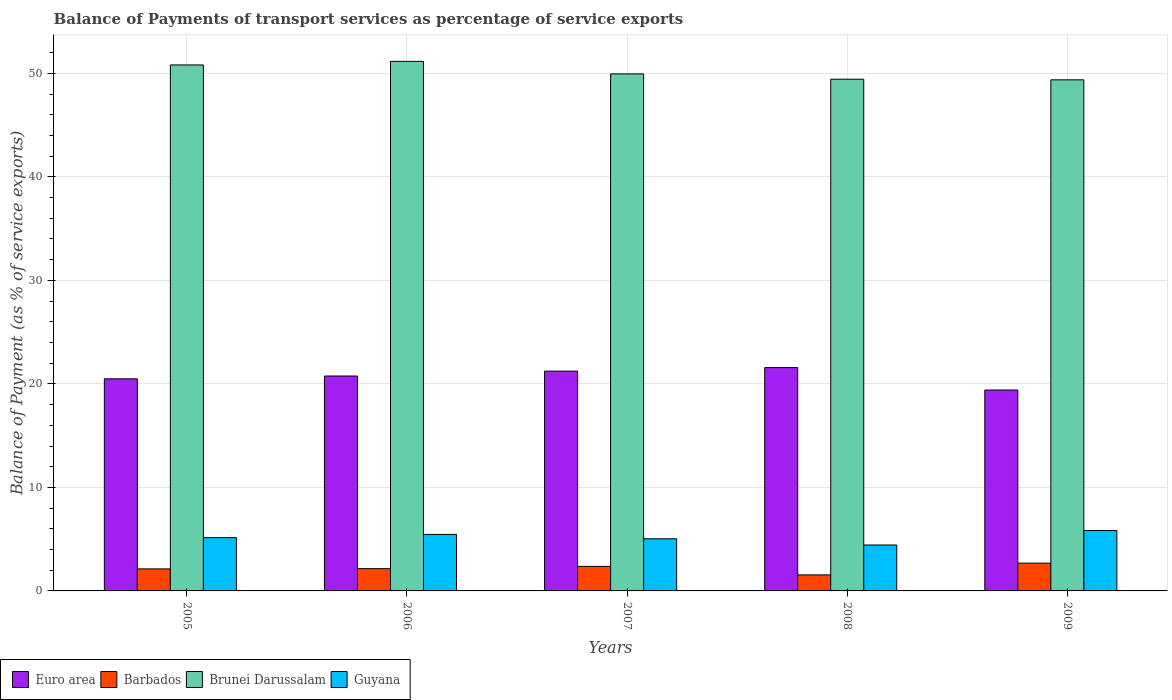How many different coloured bars are there?
Give a very brief answer. 4. How many groups of bars are there?
Your answer should be very brief. 5. Are the number of bars on each tick of the X-axis equal?
Your response must be concise. Yes. How many bars are there on the 2nd tick from the left?
Give a very brief answer. 4. How many bars are there on the 4th tick from the right?
Your response must be concise. 4. What is the label of the 1st group of bars from the left?
Give a very brief answer. 2005. What is the balance of payments of transport services in Barbados in 2007?
Provide a short and direct response. 2.37. Across all years, what is the maximum balance of payments of transport services in Guyana?
Keep it short and to the point. 5.84. Across all years, what is the minimum balance of payments of transport services in Euro area?
Keep it short and to the point. 19.41. In which year was the balance of payments of transport services in Brunei Darussalam maximum?
Keep it short and to the point. 2006. What is the total balance of payments of transport services in Brunei Darussalam in the graph?
Your response must be concise. 250.74. What is the difference between the balance of payments of transport services in Barbados in 2006 and that in 2009?
Your answer should be very brief. -0.53. What is the difference between the balance of payments of transport services in Guyana in 2007 and the balance of payments of transport services in Euro area in 2009?
Provide a succinct answer. -14.38. What is the average balance of payments of transport services in Brunei Darussalam per year?
Keep it short and to the point. 50.15. In the year 2007, what is the difference between the balance of payments of transport services in Euro area and balance of payments of transport services in Barbados?
Your answer should be compact. 18.86. In how many years, is the balance of payments of transport services in Euro area greater than 22 %?
Ensure brevity in your answer.  0. What is the ratio of the balance of payments of transport services in Guyana in 2007 to that in 2008?
Your answer should be compact. 1.13. Is the balance of payments of transport services in Barbados in 2005 less than that in 2007?
Keep it short and to the point. Yes. Is the difference between the balance of payments of transport services in Euro area in 2007 and 2009 greater than the difference between the balance of payments of transport services in Barbados in 2007 and 2009?
Your answer should be compact. Yes. What is the difference between the highest and the second highest balance of payments of transport services in Barbados?
Your response must be concise. 0.31. What is the difference between the highest and the lowest balance of payments of transport services in Euro area?
Give a very brief answer. 2.17. Is it the case that in every year, the sum of the balance of payments of transport services in Guyana and balance of payments of transport services in Barbados is greater than the sum of balance of payments of transport services in Euro area and balance of payments of transport services in Brunei Darussalam?
Offer a terse response. Yes. What does the 2nd bar from the left in 2008 represents?
Give a very brief answer. Barbados. What does the 3rd bar from the right in 2009 represents?
Offer a very short reply. Barbados. Is it the case that in every year, the sum of the balance of payments of transport services in Brunei Darussalam and balance of payments of transport services in Guyana is greater than the balance of payments of transport services in Barbados?
Your answer should be compact. Yes. Are all the bars in the graph horizontal?
Offer a terse response. No. How many years are there in the graph?
Provide a short and direct response. 5. How many legend labels are there?
Offer a very short reply. 4. What is the title of the graph?
Provide a short and direct response. Balance of Payments of transport services as percentage of service exports. What is the label or title of the Y-axis?
Your response must be concise. Balance of Payment (as % of service exports). What is the Balance of Payment (as % of service exports) in Euro area in 2005?
Keep it short and to the point. 20.49. What is the Balance of Payment (as % of service exports) of Barbados in 2005?
Provide a succinct answer. 2.13. What is the Balance of Payment (as % of service exports) of Brunei Darussalam in 2005?
Make the answer very short. 50.81. What is the Balance of Payment (as % of service exports) of Guyana in 2005?
Offer a terse response. 5.15. What is the Balance of Payment (as % of service exports) in Euro area in 2006?
Keep it short and to the point. 20.76. What is the Balance of Payment (as % of service exports) in Barbados in 2006?
Provide a succinct answer. 2.15. What is the Balance of Payment (as % of service exports) in Brunei Darussalam in 2006?
Ensure brevity in your answer.  51.16. What is the Balance of Payment (as % of service exports) of Guyana in 2006?
Your answer should be compact. 5.46. What is the Balance of Payment (as % of service exports) in Euro area in 2007?
Provide a succinct answer. 21.23. What is the Balance of Payment (as % of service exports) of Barbados in 2007?
Keep it short and to the point. 2.37. What is the Balance of Payment (as % of service exports) in Brunei Darussalam in 2007?
Give a very brief answer. 49.95. What is the Balance of Payment (as % of service exports) in Guyana in 2007?
Provide a succinct answer. 5.03. What is the Balance of Payment (as % of service exports) of Euro area in 2008?
Your answer should be compact. 21.58. What is the Balance of Payment (as % of service exports) in Barbados in 2008?
Ensure brevity in your answer.  1.55. What is the Balance of Payment (as % of service exports) of Brunei Darussalam in 2008?
Your response must be concise. 49.44. What is the Balance of Payment (as % of service exports) in Guyana in 2008?
Your answer should be very brief. 4.44. What is the Balance of Payment (as % of service exports) of Euro area in 2009?
Provide a short and direct response. 19.41. What is the Balance of Payment (as % of service exports) of Barbados in 2009?
Make the answer very short. 2.68. What is the Balance of Payment (as % of service exports) in Brunei Darussalam in 2009?
Make the answer very short. 49.38. What is the Balance of Payment (as % of service exports) in Guyana in 2009?
Give a very brief answer. 5.84. Across all years, what is the maximum Balance of Payment (as % of service exports) in Euro area?
Your answer should be compact. 21.58. Across all years, what is the maximum Balance of Payment (as % of service exports) in Barbados?
Provide a short and direct response. 2.68. Across all years, what is the maximum Balance of Payment (as % of service exports) in Brunei Darussalam?
Provide a succinct answer. 51.16. Across all years, what is the maximum Balance of Payment (as % of service exports) in Guyana?
Make the answer very short. 5.84. Across all years, what is the minimum Balance of Payment (as % of service exports) in Euro area?
Provide a succinct answer. 19.41. Across all years, what is the minimum Balance of Payment (as % of service exports) of Barbados?
Provide a short and direct response. 1.55. Across all years, what is the minimum Balance of Payment (as % of service exports) of Brunei Darussalam?
Offer a terse response. 49.38. Across all years, what is the minimum Balance of Payment (as % of service exports) in Guyana?
Your answer should be compact. 4.44. What is the total Balance of Payment (as % of service exports) in Euro area in the graph?
Provide a short and direct response. 103.47. What is the total Balance of Payment (as % of service exports) of Barbados in the graph?
Provide a short and direct response. 10.89. What is the total Balance of Payment (as % of service exports) of Brunei Darussalam in the graph?
Offer a terse response. 250.74. What is the total Balance of Payment (as % of service exports) in Guyana in the graph?
Provide a succinct answer. 25.91. What is the difference between the Balance of Payment (as % of service exports) of Euro area in 2005 and that in 2006?
Your response must be concise. -0.27. What is the difference between the Balance of Payment (as % of service exports) of Barbados in 2005 and that in 2006?
Your answer should be compact. -0.02. What is the difference between the Balance of Payment (as % of service exports) of Brunei Darussalam in 2005 and that in 2006?
Your answer should be compact. -0.35. What is the difference between the Balance of Payment (as % of service exports) of Guyana in 2005 and that in 2006?
Ensure brevity in your answer.  -0.31. What is the difference between the Balance of Payment (as % of service exports) in Euro area in 2005 and that in 2007?
Keep it short and to the point. -0.74. What is the difference between the Balance of Payment (as % of service exports) in Barbados in 2005 and that in 2007?
Offer a very short reply. -0.24. What is the difference between the Balance of Payment (as % of service exports) in Brunei Darussalam in 2005 and that in 2007?
Provide a short and direct response. 0.86. What is the difference between the Balance of Payment (as % of service exports) of Guyana in 2005 and that in 2007?
Offer a very short reply. 0.11. What is the difference between the Balance of Payment (as % of service exports) of Euro area in 2005 and that in 2008?
Make the answer very short. -1.09. What is the difference between the Balance of Payment (as % of service exports) in Barbados in 2005 and that in 2008?
Keep it short and to the point. 0.58. What is the difference between the Balance of Payment (as % of service exports) of Brunei Darussalam in 2005 and that in 2008?
Your answer should be very brief. 1.38. What is the difference between the Balance of Payment (as % of service exports) of Guyana in 2005 and that in 2008?
Ensure brevity in your answer.  0.71. What is the difference between the Balance of Payment (as % of service exports) of Euro area in 2005 and that in 2009?
Your answer should be compact. 1.08. What is the difference between the Balance of Payment (as % of service exports) of Barbados in 2005 and that in 2009?
Offer a terse response. -0.56. What is the difference between the Balance of Payment (as % of service exports) in Brunei Darussalam in 2005 and that in 2009?
Provide a short and direct response. 1.44. What is the difference between the Balance of Payment (as % of service exports) in Guyana in 2005 and that in 2009?
Give a very brief answer. -0.69. What is the difference between the Balance of Payment (as % of service exports) in Euro area in 2006 and that in 2007?
Provide a short and direct response. -0.47. What is the difference between the Balance of Payment (as % of service exports) of Barbados in 2006 and that in 2007?
Make the answer very short. -0.22. What is the difference between the Balance of Payment (as % of service exports) in Brunei Darussalam in 2006 and that in 2007?
Provide a succinct answer. 1.21. What is the difference between the Balance of Payment (as % of service exports) of Guyana in 2006 and that in 2007?
Your response must be concise. 0.42. What is the difference between the Balance of Payment (as % of service exports) in Euro area in 2006 and that in 2008?
Make the answer very short. -0.81. What is the difference between the Balance of Payment (as % of service exports) in Barbados in 2006 and that in 2008?
Provide a succinct answer. 0.6. What is the difference between the Balance of Payment (as % of service exports) of Brunei Darussalam in 2006 and that in 2008?
Provide a succinct answer. 1.73. What is the difference between the Balance of Payment (as % of service exports) in Guyana in 2006 and that in 2008?
Ensure brevity in your answer.  1.02. What is the difference between the Balance of Payment (as % of service exports) in Euro area in 2006 and that in 2009?
Your answer should be compact. 1.35. What is the difference between the Balance of Payment (as % of service exports) in Barbados in 2006 and that in 2009?
Give a very brief answer. -0.53. What is the difference between the Balance of Payment (as % of service exports) of Brunei Darussalam in 2006 and that in 2009?
Ensure brevity in your answer.  1.79. What is the difference between the Balance of Payment (as % of service exports) in Guyana in 2006 and that in 2009?
Your answer should be compact. -0.38. What is the difference between the Balance of Payment (as % of service exports) of Euro area in 2007 and that in 2008?
Make the answer very short. -0.34. What is the difference between the Balance of Payment (as % of service exports) of Barbados in 2007 and that in 2008?
Give a very brief answer. 0.82. What is the difference between the Balance of Payment (as % of service exports) in Brunei Darussalam in 2007 and that in 2008?
Your answer should be very brief. 0.51. What is the difference between the Balance of Payment (as % of service exports) in Guyana in 2007 and that in 2008?
Ensure brevity in your answer.  0.6. What is the difference between the Balance of Payment (as % of service exports) of Euro area in 2007 and that in 2009?
Your answer should be compact. 1.82. What is the difference between the Balance of Payment (as % of service exports) in Barbados in 2007 and that in 2009?
Give a very brief answer. -0.31. What is the difference between the Balance of Payment (as % of service exports) in Brunei Darussalam in 2007 and that in 2009?
Offer a very short reply. 0.57. What is the difference between the Balance of Payment (as % of service exports) of Guyana in 2007 and that in 2009?
Offer a terse response. -0.8. What is the difference between the Balance of Payment (as % of service exports) in Euro area in 2008 and that in 2009?
Give a very brief answer. 2.17. What is the difference between the Balance of Payment (as % of service exports) in Barbados in 2008 and that in 2009?
Make the answer very short. -1.13. What is the difference between the Balance of Payment (as % of service exports) in Brunei Darussalam in 2008 and that in 2009?
Keep it short and to the point. 0.06. What is the difference between the Balance of Payment (as % of service exports) in Guyana in 2008 and that in 2009?
Offer a terse response. -1.4. What is the difference between the Balance of Payment (as % of service exports) of Euro area in 2005 and the Balance of Payment (as % of service exports) of Barbados in 2006?
Keep it short and to the point. 18.34. What is the difference between the Balance of Payment (as % of service exports) of Euro area in 2005 and the Balance of Payment (as % of service exports) of Brunei Darussalam in 2006?
Give a very brief answer. -30.67. What is the difference between the Balance of Payment (as % of service exports) of Euro area in 2005 and the Balance of Payment (as % of service exports) of Guyana in 2006?
Offer a terse response. 15.03. What is the difference between the Balance of Payment (as % of service exports) of Barbados in 2005 and the Balance of Payment (as % of service exports) of Brunei Darussalam in 2006?
Keep it short and to the point. -49.03. What is the difference between the Balance of Payment (as % of service exports) in Barbados in 2005 and the Balance of Payment (as % of service exports) in Guyana in 2006?
Your response must be concise. -3.33. What is the difference between the Balance of Payment (as % of service exports) in Brunei Darussalam in 2005 and the Balance of Payment (as % of service exports) in Guyana in 2006?
Provide a succinct answer. 45.36. What is the difference between the Balance of Payment (as % of service exports) of Euro area in 2005 and the Balance of Payment (as % of service exports) of Barbados in 2007?
Keep it short and to the point. 18.12. What is the difference between the Balance of Payment (as % of service exports) in Euro area in 2005 and the Balance of Payment (as % of service exports) in Brunei Darussalam in 2007?
Your answer should be very brief. -29.46. What is the difference between the Balance of Payment (as % of service exports) of Euro area in 2005 and the Balance of Payment (as % of service exports) of Guyana in 2007?
Provide a succinct answer. 15.46. What is the difference between the Balance of Payment (as % of service exports) of Barbados in 2005 and the Balance of Payment (as % of service exports) of Brunei Darussalam in 2007?
Your answer should be very brief. -47.82. What is the difference between the Balance of Payment (as % of service exports) in Barbados in 2005 and the Balance of Payment (as % of service exports) in Guyana in 2007?
Provide a succinct answer. -2.91. What is the difference between the Balance of Payment (as % of service exports) of Brunei Darussalam in 2005 and the Balance of Payment (as % of service exports) of Guyana in 2007?
Make the answer very short. 45.78. What is the difference between the Balance of Payment (as % of service exports) in Euro area in 2005 and the Balance of Payment (as % of service exports) in Barbados in 2008?
Your answer should be very brief. 18.94. What is the difference between the Balance of Payment (as % of service exports) in Euro area in 2005 and the Balance of Payment (as % of service exports) in Brunei Darussalam in 2008?
Your answer should be compact. -28.94. What is the difference between the Balance of Payment (as % of service exports) of Euro area in 2005 and the Balance of Payment (as % of service exports) of Guyana in 2008?
Give a very brief answer. 16.05. What is the difference between the Balance of Payment (as % of service exports) in Barbados in 2005 and the Balance of Payment (as % of service exports) in Brunei Darussalam in 2008?
Give a very brief answer. -47.31. What is the difference between the Balance of Payment (as % of service exports) in Barbados in 2005 and the Balance of Payment (as % of service exports) in Guyana in 2008?
Your answer should be very brief. -2.31. What is the difference between the Balance of Payment (as % of service exports) of Brunei Darussalam in 2005 and the Balance of Payment (as % of service exports) of Guyana in 2008?
Offer a very short reply. 46.38. What is the difference between the Balance of Payment (as % of service exports) of Euro area in 2005 and the Balance of Payment (as % of service exports) of Barbados in 2009?
Give a very brief answer. 17.81. What is the difference between the Balance of Payment (as % of service exports) in Euro area in 2005 and the Balance of Payment (as % of service exports) in Brunei Darussalam in 2009?
Make the answer very short. -28.88. What is the difference between the Balance of Payment (as % of service exports) of Euro area in 2005 and the Balance of Payment (as % of service exports) of Guyana in 2009?
Ensure brevity in your answer.  14.66. What is the difference between the Balance of Payment (as % of service exports) in Barbados in 2005 and the Balance of Payment (as % of service exports) in Brunei Darussalam in 2009?
Ensure brevity in your answer.  -47.25. What is the difference between the Balance of Payment (as % of service exports) in Barbados in 2005 and the Balance of Payment (as % of service exports) in Guyana in 2009?
Provide a short and direct response. -3.71. What is the difference between the Balance of Payment (as % of service exports) in Brunei Darussalam in 2005 and the Balance of Payment (as % of service exports) in Guyana in 2009?
Keep it short and to the point. 44.98. What is the difference between the Balance of Payment (as % of service exports) in Euro area in 2006 and the Balance of Payment (as % of service exports) in Barbados in 2007?
Offer a very short reply. 18.39. What is the difference between the Balance of Payment (as % of service exports) in Euro area in 2006 and the Balance of Payment (as % of service exports) in Brunei Darussalam in 2007?
Ensure brevity in your answer.  -29.19. What is the difference between the Balance of Payment (as % of service exports) in Euro area in 2006 and the Balance of Payment (as % of service exports) in Guyana in 2007?
Your answer should be very brief. 15.73. What is the difference between the Balance of Payment (as % of service exports) in Barbados in 2006 and the Balance of Payment (as % of service exports) in Brunei Darussalam in 2007?
Keep it short and to the point. -47.8. What is the difference between the Balance of Payment (as % of service exports) of Barbados in 2006 and the Balance of Payment (as % of service exports) of Guyana in 2007?
Offer a very short reply. -2.88. What is the difference between the Balance of Payment (as % of service exports) of Brunei Darussalam in 2006 and the Balance of Payment (as % of service exports) of Guyana in 2007?
Your answer should be compact. 46.13. What is the difference between the Balance of Payment (as % of service exports) of Euro area in 2006 and the Balance of Payment (as % of service exports) of Barbados in 2008?
Ensure brevity in your answer.  19.21. What is the difference between the Balance of Payment (as % of service exports) in Euro area in 2006 and the Balance of Payment (as % of service exports) in Brunei Darussalam in 2008?
Provide a short and direct response. -28.67. What is the difference between the Balance of Payment (as % of service exports) in Euro area in 2006 and the Balance of Payment (as % of service exports) in Guyana in 2008?
Provide a short and direct response. 16.33. What is the difference between the Balance of Payment (as % of service exports) in Barbados in 2006 and the Balance of Payment (as % of service exports) in Brunei Darussalam in 2008?
Your response must be concise. -47.28. What is the difference between the Balance of Payment (as % of service exports) in Barbados in 2006 and the Balance of Payment (as % of service exports) in Guyana in 2008?
Make the answer very short. -2.29. What is the difference between the Balance of Payment (as % of service exports) of Brunei Darussalam in 2006 and the Balance of Payment (as % of service exports) of Guyana in 2008?
Ensure brevity in your answer.  46.72. What is the difference between the Balance of Payment (as % of service exports) in Euro area in 2006 and the Balance of Payment (as % of service exports) in Barbados in 2009?
Keep it short and to the point. 18.08. What is the difference between the Balance of Payment (as % of service exports) of Euro area in 2006 and the Balance of Payment (as % of service exports) of Brunei Darussalam in 2009?
Keep it short and to the point. -28.61. What is the difference between the Balance of Payment (as % of service exports) of Euro area in 2006 and the Balance of Payment (as % of service exports) of Guyana in 2009?
Provide a succinct answer. 14.93. What is the difference between the Balance of Payment (as % of service exports) in Barbados in 2006 and the Balance of Payment (as % of service exports) in Brunei Darussalam in 2009?
Your response must be concise. -47.22. What is the difference between the Balance of Payment (as % of service exports) in Barbados in 2006 and the Balance of Payment (as % of service exports) in Guyana in 2009?
Your answer should be very brief. -3.68. What is the difference between the Balance of Payment (as % of service exports) of Brunei Darussalam in 2006 and the Balance of Payment (as % of service exports) of Guyana in 2009?
Your answer should be compact. 45.33. What is the difference between the Balance of Payment (as % of service exports) of Euro area in 2007 and the Balance of Payment (as % of service exports) of Barbados in 2008?
Make the answer very short. 19.68. What is the difference between the Balance of Payment (as % of service exports) in Euro area in 2007 and the Balance of Payment (as % of service exports) in Brunei Darussalam in 2008?
Offer a terse response. -28.2. What is the difference between the Balance of Payment (as % of service exports) in Euro area in 2007 and the Balance of Payment (as % of service exports) in Guyana in 2008?
Ensure brevity in your answer.  16.8. What is the difference between the Balance of Payment (as % of service exports) of Barbados in 2007 and the Balance of Payment (as % of service exports) of Brunei Darussalam in 2008?
Your response must be concise. -47.06. What is the difference between the Balance of Payment (as % of service exports) of Barbados in 2007 and the Balance of Payment (as % of service exports) of Guyana in 2008?
Provide a succinct answer. -2.06. What is the difference between the Balance of Payment (as % of service exports) in Brunei Darussalam in 2007 and the Balance of Payment (as % of service exports) in Guyana in 2008?
Your answer should be very brief. 45.51. What is the difference between the Balance of Payment (as % of service exports) of Euro area in 2007 and the Balance of Payment (as % of service exports) of Barbados in 2009?
Your answer should be compact. 18.55. What is the difference between the Balance of Payment (as % of service exports) of Euro area in 2007 and the Balance of Payment (as % of service exports) of Brunei Darussalam in 2009?
Make the answer very short. -28.14. What is the difference between the Balance of Payment (as % of service exports) of Euro area in 2007 and the Balance of Payment (as % of service exports) of Guyana in 2009?
Keep it short and to the point. 15.4. What is the difference between the Balance of Payment (as % of service exports) in Barbados in 2007 and the Balance of Payment (as % of service exports) in Brunei Darussalam in 2009?
Offer a terse response. -47. What is the difference between the Balance of Payment (as % of service exports) of Barbados in 2007 and the Balance of Payment (as % of service exports) of Guyana in 2009?
Provide a short and direct response. -3.46. What is the difference between the Balance of Payment (as % of service exports) of Brunei Darussalam in 2007 and the Balance of Payment (as % of service exports) of Guyana in 2009?
Give a very brief answer. 44.11. What is the difference between the Balance of Payment (as % of service exports) of Euro area in 2008 and the Balance of Payment (as % of service exports) of Barbados in 2009?
Offer a terse response. 18.89. What is the difference between the Balance of Payment (as % of service exports) in Euro area in 2008 and the Balance of Payment (as % of service exports) in Brunei Darussalam in 2009?
Keep it short and to the point. -27.8. What is the difference between the Balance of Payment (as % of service exports) of Euro area in 2008 and the Balance of Payment (as % of service exports) of Guyana in 2009?
Your answer should be compact. 15.74. What is the difference between the Balance of Payment (as % of service exports) in Barbados in 2008 and the Balance of Payment (as % of service exports) in Brunei Darussalam in 2009?
Make the answer very short. -47.83. What is the difference between the Balance of Payment (as % of service exports) in Barbados in 2008 and the Balance of Payment (as % of service exports) in Guyana in 2009?
Make the answer very short. -4.29. What is the difference between the Balance of Payment (as % of service exports) in Brunei Darussalam in 2008 and the Balance of Payment (as % of service exports) in Guyana in 2009?
Provide a short and direct response. 43.6. What is the average Balance of Payment (as % of service exports) of Euro area per year?
Your answer should be compact. 20.69. What is the average Balance of Payment (as % of service exports) in Barbados per year?
Make the answer very short. 2.18. What is the average Balance of Payment (as % of service exports) of Brunei Darussalam per year?
Give a very brief answer. 50.15. What is the average Balance of Payment (as % of service exports) of Guyana per year?
Ensure brevity in your answer.  5.18. In the year 2005, what is the difference between the Balance of Payment (as % of service exports) in Euro area and Balance of Payment (as % of service exports) in Barbados?
Make the answer very short. 18.36. In the year 2005, what is the difference between the Balance of Payment (as % of service exports) of Euro area and Balance of Payment (as % of service exports) of Brunei Darussalam?
Ensure brevity in your answer.  -30.32. In the year 2005, what is the difference between the Balance of Payment (as % of service exports) in Euro area and Balance of Payment (as % of service exports) in Guyana?
Offer a very short reply. 15.35. In the year 2005, what is the difference between the Balance of Payment (as % of service exports) of Barbados and Balance of Payment (as % of service exports) of Brunei Darussalam?
Make the answer very short. -48.69. In the year 2005, what is the difference between the Balance of Payment (as % of service exports) in Barbados and Balance of Payment (as % of service exports) in Guyana?
Provide a succinct answer. -3.02. In the year 2005, what is the difference between the Balance of Payment (as % of service exports) in Brunei Darussalam and Balance of Payment (as % of service exports) in Guyana?
Provide a succinct answer. 45.67. In the year 2006, what is the difference between the Balance of Payment (as % of service exports) of Euro area and Balance of Payment (as % of service exports) of Barbados?
Offer a terse response. 18.61. In the year 2006, what is the difference between the Balance of Payment (as % of service exports) of Euro area and Balance of Payment (as % of service exports) of Brunei Darussalam?
Keep it short and to the point. -30.4. In the year 2006, what is the difference between the Balance of Payment (as % of service exports) in Euro area and Balance of Payment (as % of service exports) in Guyana?
Provide a succinct answer. 15.3. In the year 2006, what is the difference between the Balance of Payment (as % of service exports) of Barbados and Balance of Payment (as % of service exports) of Brunei Darussalam?
Make the answer very short. -49.01. In the year 2006, what is the difference between the Balance of Payment (as % of service exports) of Barbados and Balance of Payment (as % of service exports) of Guyana?
Ensure brevity in your answer.  -3.31. In the year 2006, what is the difference between the Balance of Payment (as % of service exports) in Brunei Darussalam and Balance of Payment (as % of service exports) in Guyana?
Make the answer very short. 45.7. In the year 2007, what is the difference between the Balance of Payment (as % of service exports) in Euro area and Balance of Payment (as % of service exports) in Barbados?
Your answer should be compact. 18.86. In the year 2007, what is the difference between the Balance of Payment (as % of service exports) in Euro area and Balance of Payment (as % of service exports) in Brunei Darussalam?
Your answer should be compact. -28.72. In the year 2007, what is the difference between the Balance of Payment (as % of service exports) of Euro area and Balance of Payment (as % of service exports) of Guyana?
Keep it short and to the point. 16.2. In the year 2007, what is the difference between the Balance of Payment (as % of service exports) of Barbados and Balance of Payment (as % of service exports) of Brunei Darussalam?
Provide a short and direct response. -47.58. In the year 2007, what is the difference between the Balance of Payment (as % of service exports) in Barbados and Balance of Payment (as % of service exports) in Guyana?
Ensure brevity in your answer.  -2.66. In the year 2007, what is the difference between the Balance of Payment (as % of service exports) of Brunei Darussalam and Balance of Payment (as % of service exports) of Guyana?
Your answer should be compact. 44.92. In the year 2008, what is the difference between the Balance of Payment (as % of service exports) in Euro area and Balance of Payment (as % of service exports) in Barbados?
Provide a short and direct response. 20.03. In the year 2008, what is the difference between the Balance of Payment (as % of service exports) of Euro area and Balance of Payment (as % of service exports) of Brunei Darussalam?
Your answer should be very brief. -27.86. In the year 2008, what is the difference between the Balance of Payment (as % of service exports) in Euro area and Balance of Payment (as % of service exports) in Guyana?
Ensure brevity in your answer.  17.14. In the year 2008, what is the difference between the Balance of Payment (as % of service exports) of Barbados and Balance of Payment (as % of service exports) of Brunei Darussalam?
Offer a terse response. -47.89. In the year 2008, what is the difference between the Balance of Payment (as % of service exports) of Barbados and Balance of Payment (as % of service exports) of Guyana?
Keep it short and to the point. -2.89. In the year 2008, what is the difference between the Balance of Payment (as % of service exports) in Brunei Darussalam and Balance of Payment (as % of service exports) in Guyana?
Make the answer very short. 45. In the year 2009, what is the difference between the Balance of Payment (as % of service exports) of Euro area and Balance of Payment (as % of service exports) of Barbados?
Your answer should be very brief. 16.73. In the year 2009, what is the difference between the Balance of Payment (as % of service exports) in Euro area and Balance of Payment (as % of service exports) in Brunei Darussalam?
Keep it short and to the point. -29.97. In the year 2009, what is the difference between the Balance of Payment (as % of service exports) of Euro area and Balance of Payment (as % of service exports) of Guyana?
Provide a succinct answer. 13.57. In the year 2009, what is the difference between the Balance of Payment (as % of service exports) of Barbados and Balance of Payment (as % of service exports) of Brunei Darussalam?
Provide a succinct answer. -46.69. In the year 2009, what is the difference between the Balance of Payment (as % of service exports) in Barbados and Balance of Payment (as % of service exports) in Guyana?
Provide a succinct answer. -3.15. In the year 2009, what is the difference between the Balance of Payment (as % of service exports) of Brunei Darussalam and Balance of Payment (as % of service exports) of Guyana?
Your answer should be compact. 43.54. What is the ratio of the Balance of Payment (as % of service exports) in Euro area in 2005 to that in 2006?
Offer a terse response. 0.99. What is the ratio of the Balance of Payment (as % of service exports) in Guyana in 2005 to that in 2006?
Provide a succinct answer. 0.94. What is the ratio of the Balance of Payment (as % of service exports) of Euro area in 2005 to that in 2007?
Offer a very short reply. 0.96. What is the ratio of the Balance of Payment (as % of service exports) in Barbados in 2005 to that in 2007?
Keep it short and to the point. 0.9. What is the ratio of the Balance of Payment (as % of service exports) in Brunei Darussalam in 2005 to that in 2007?
Your response must be concise. 1.02. What is the ratio of the Balance of Payment (as % of service exports) in Guyana in 2005 to that in 2007?
Your response must be concise. 1.02. What is the ratio of the Balance of Payment (as % of service exports) in Euro area in 2005 to that in 2008?
Provide a short and direct response. 0.95. What is the ratio of the Balance of Payment (as % of service exports) of Barbados in 2005 to that in 2008?
Ensure brevity in your answer.  1.37. What is the ratio of the Balance of Payment (as % of service exports) in Brunei Darussalam in 2005 to that in 2008?
Offer a very short reply. 1.03. What is the ratio of the Balance of Payment (as % of service exports) in Guyana in 2005 to that in 2008?
Give a very brief answer. 1.16. What is the ratio of the Balance of Payment (as % of service exports) of Euro area in 2005 to that in 2009?
Give a very brief answer. 1.06. What is the ratio of the Balance of Payment (as % of service exports) in Barbados in 2005 to that in 2009?
Keep it short and to the point. 0.79. What is the ratio of the Balance of Payment (as % of service exports) in Brunei Darussalam in 2005 to that in 2009?
Offer a very short reply. 1.03. What is the ratio of the Balance of Payment (as % of service exports) of Guyana in 2005 to that in 2009?
Make the answer very short. 0.88. What is the ratio of the Balance of Payment (as % of service exports) of Euro area in 2006 to that in 2007?
Offer a very short reply. 0.98. What is the ratio of the Balance of Payment (as % of service exports) in Barbados in 2006 to that in 2007?
Your answer should be very brief. 0.91. What is the ratio of the Balance of Payment (as % of service exports) of Brunei Darussalam in 2006 to that in 2007?
Your answer should be compact. 1.02. What is the ratio of the Balance of Payment (as % of service exports) in Guyana in 2006 to that in 2007?
Your answer should be compact. 1.08. What is the ratio of the Balance of Payment (as % of service exports) in Euro area in 2006 to that in 2008?
Offer a terse response. 0.96. What is the ratio of the Balance of Payment (as % of service exports) of Barbados in 2006 to that in 2008?
Provide a succinct answer. 1.39. What is the ratio of the Balance of Payment (as % of service exports) in Brunei Darussalam in 2006 to that in 2008?
Give a very brief answer. 1.03. What is the ratio of the Balance of Payment (as % of service exports) of Guyana in 2006 to that in 2008?
Provide a short and direct response. 1.23. What is the ratio of the Balance of Payment (as % of service exports) in Euro area in 2006 to that in 2009?
Provide a succinct answer. 1.07. What is the ratio of the Balance of Payment (as % of service exports) of Barbados in 2006 to that in 2009?
Your answer should be compact. 0.8. What is the ratio of the Balance of Payment (as % of service exports) in Brunei Darussalam in 2006 to that in 2009?
Provide a succinct answer. 1.04. What is the ratio of the Balance of Payment (as % of service exports) of Guyana in 2006 to that in 2009?
Offer a terse response. 0.94. What is the ratio of the Balance of Payment (as % of service exports) of Euro area in 2007 to that in 2008?
Your answer should be compact. 0.98. What is the ratio of the Balance of Payment (as % of service exports) in Barbados in 2007 to that in 2008?
Offer a very short reply. 1.53. What is the ratio of the Balance of Payment (as % of service exports) of Brunei Darussalam in 2007 to that in 2008?
Keep it short and to the point. 1.01. What is the ratio of the Balance of Payment (as % of service exports) of Guyana in 2007 to that in 2008?
Provide a short and direct response. 1.13. What is the ratio of the Balance of Payment (as % of service exports) in Euro area in 2007 to that in 2009?
Make the answer very short. 1.09. What is the ratio of the Balance of Payment (as % of service exports) of Barbados in 2007 to that in 2009?
Offer a terse response. 0.88. What is the ratio of the Balance of Payment (as % of service exports) in Brunei Darussalam in 2007 to that in 2009?
Your answer should be compact. 1.01. What is the ratio of the Balance of Payment (as % of service exports) of Guyana in 2007 to that in 2009?
Your response must be concise. 0.86. What is the ratio of the Balance of Payment (as % of service exports) of Euro area in 2008 to that in 2009?
Your answer should be very brief. 1.11. What is the ratio of the Balance of Payment (as % of service exports) of Barbados in 2008 to that in 2009?
Provide a short and direct response. 0.58. What is the ratio of the Balance of Payment (as % of service exports) in Brunei Darussalam in 2008 to that in 2009?
Provide a short and direct response. 1. What is the ratio of the Balance of Payment (as % of service exports) in Guyana in 2008 to that in 2009?
Keep it short and to the point. 0.76. What is the difference between the highest and the second highest Balance of Payment (as % of service exports) of Euro area?
Make the answer very short. 0.34. What is the difference between the highest and the second highest Balance of Payment (as % of service exports) of Barbados?
Provide a succinct answer. 0.31. What is the difference between the highest and the second highest Balance of Payment (as % of service exports) in Brunei Darussalam?
Provide a short and direct response. 0.35. What is the difference between the highest and the second highest Balance of Payment (as % of service exports) in Guyana?
Keep it short and to the point. 0.38. What is the difference between the highest and the lowest Balance of Payment (as % of service exports) of Euro area?
Keep it short and to the point. 2.17. What is the difference between the highest and the lowest Balance of Payment (as % of service exports) in Barbados?
Provide a short and direct response. 1.13. What is the difference between the highest and the lowest Balance of Payment (as % of service exports) of Brunei Darussalam?
Your answer should be very brief. 1.79. What is the difference between the highest and the lowest Balance of Payment (as % of service exports) in Guyana?
Make the answer very short. 1.4. 